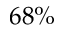<formula> <loc_0><loc_0><loc_500><loc_500>6 8 \%</formula> 